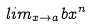<formula> <loc_0><loc_0><loc_500><loc_500>l i m _ { x \rightarrow a } b x ^ { n }</formula> 